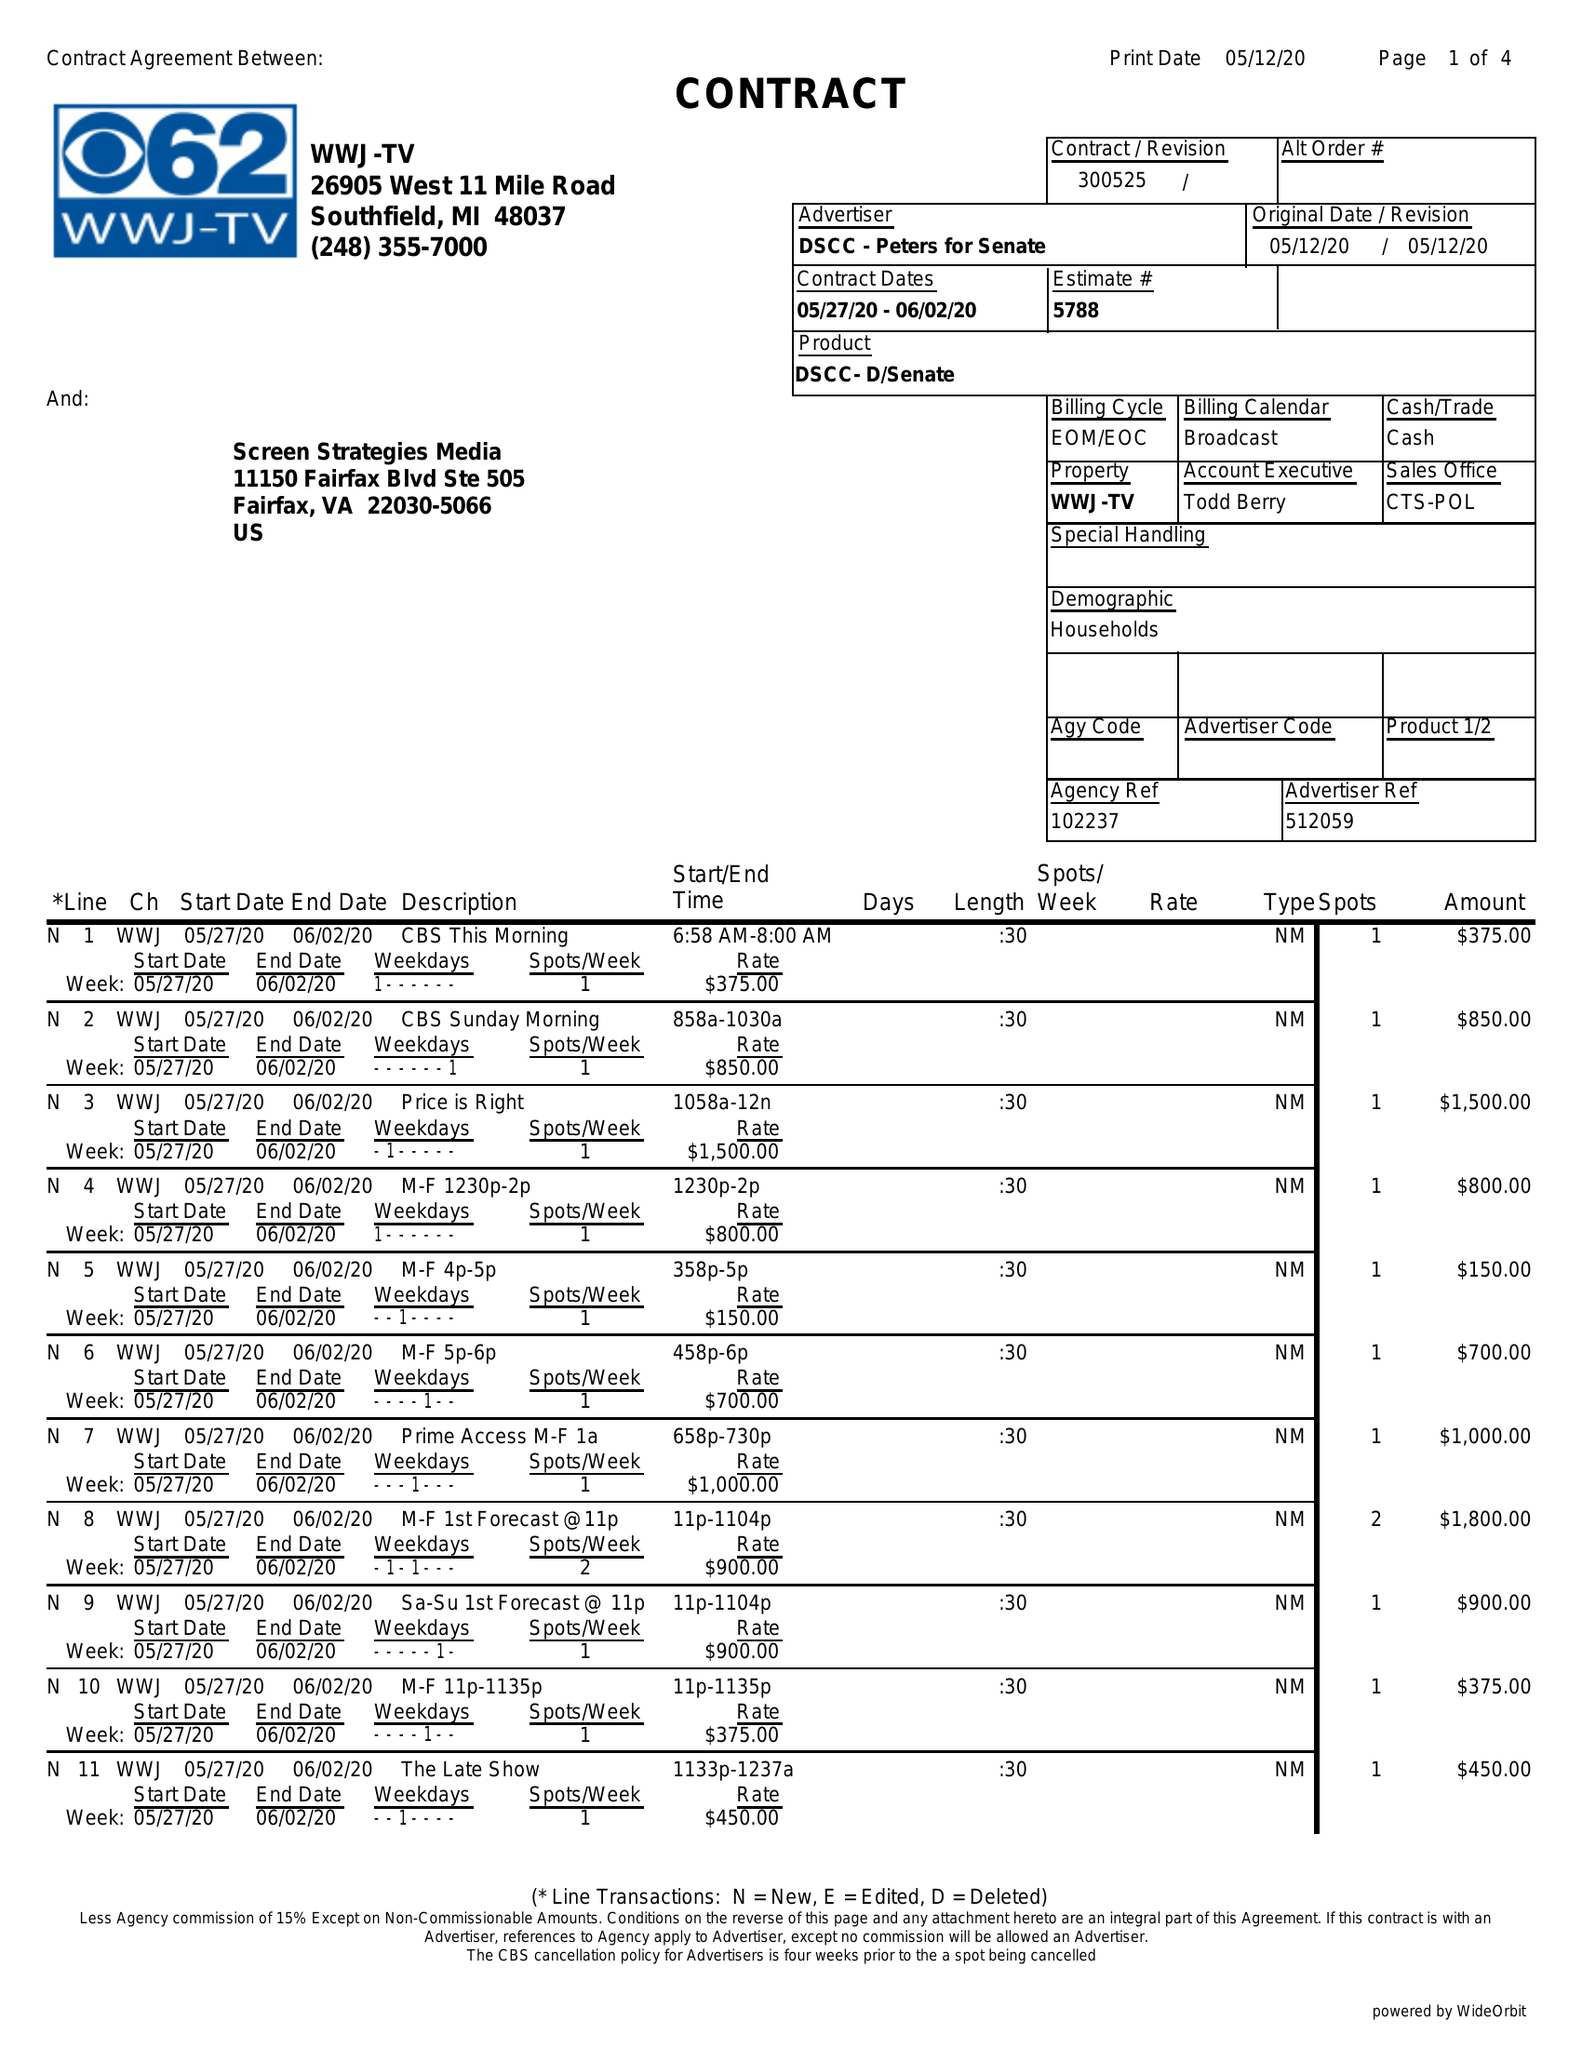What is the value for the advertiser?
Answer the question using a single word or phrase. DSCC - PETERS FOR SENATE 